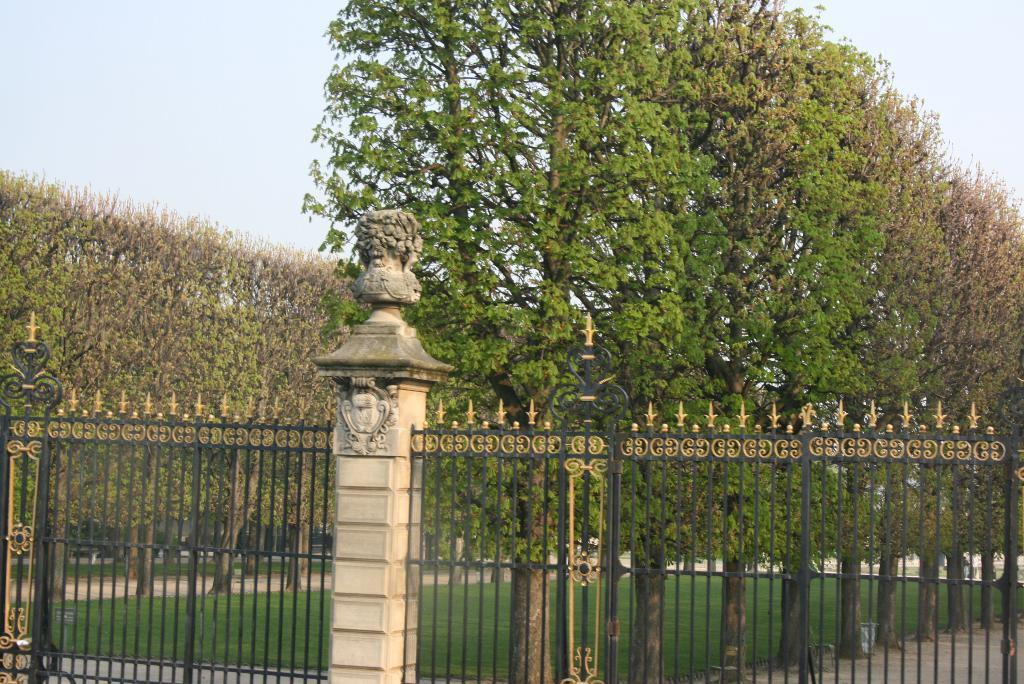What type of structure can be seen in the image? There is a fencing in the image. Is there anything attached to the fencing? Yes, there is a pillar attached to the fencing. What is on the pillar? The pillar has sculptors on it. What can be seen in the background of the image? There is water, trees, and plants visible in the image. How many knees can be seen on the sculptors in the image? There are no knees visible on the sculptors in the image, as they are not depicted in a way that shows their legs or joints. 